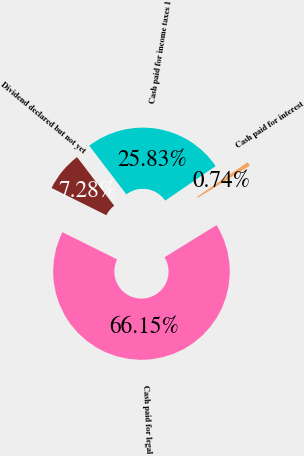<chart> <loc_0><loc_0><loc_500><loc_500><pie_chart><fcel>Cash paid for income taxes 1<fcel>Cash paid for interest<fcel>Cash paid for legal<fcel>Dividend declared but not yet<nl><fcel>25.83%<fcel>0.74%<fcel>66.16%<fcel>7.28%<nl></chart> 